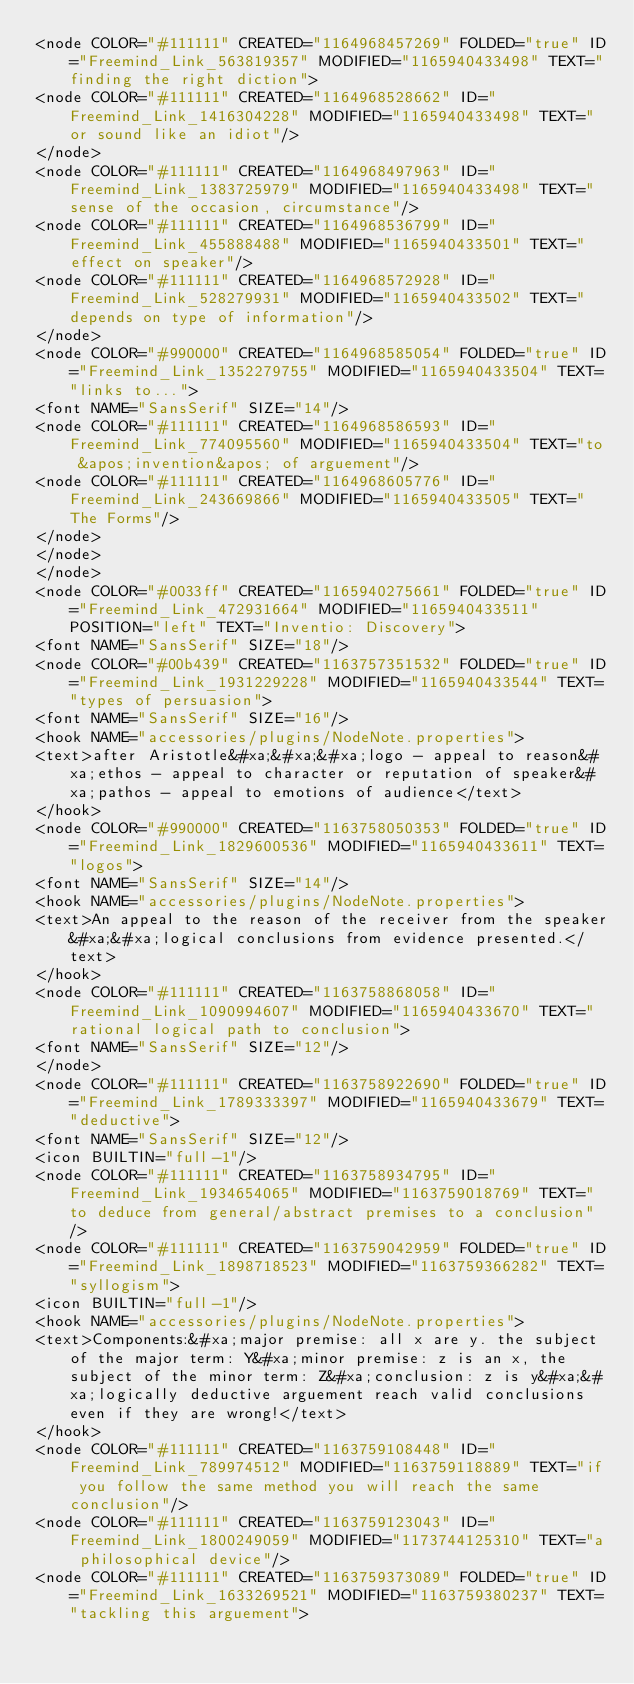Convert code to text. <code><loc_0><loc_0><loc_500><loc_500><_ObjectiveC_><node COLOR="#111111" CREATED="1164968457269" FOLDED="true" ID="Freemind_Link_563819357" MODIFIED="1165940433498" TEXT="finding the right diction">
<node COLOR="#111111" CREATED="1164968528662" ID="Freemind_Link_1416304228" MODIFIED="1165940433498" TEXT="or sound like an idiot"/>
</node>
<node COLOR="#111111" CREATED="1164968497963" ID="Freemind_Link_1383725979" MODIFIED="1165940433498" TEXT="sense of the occasion, circumstance"/>
<node COLOR="#111111" CREATED="1164968536799" ID="Freemind_Link_455888488" MODIFIED="1165940433501" TEXT="effect on speaker"/>
<node COLOR="#111111" CREATED="1164968572928" ID="Freemind_Link_528279931" MODIFIED="1165940433502" TEXT="depends on type of information"/>
</node>
<node COLOR="#990000" CREATED="1164968585054" FOLDED="true" ID="Freemind_Link_1352279755" MODIFIED="1165940433504" TEXT="links to...">
<font NAME="SansSerif" SIZE="14"/>
<node COLOR="#111111" CREATED="1164968586593" ID="Freemind_Link_774095560" MODIFIED="1165940433504" TEXT="to &apos;invention&apos; of arguement"/>
<node COLOR="#111111" CREATED="1164968605776" ID="Freemind_Link_243669866" MODIFIED="1165940433505" TEXT="The Forms"/>
</node>
</node>
</node>
<node COLOR="#0033ff" CREATED="1165940275661" FOLDED="true" ID="Freemind_Link_472931664" MODIFIED="1165940433511" POSITION="left" TEXT="Inventio: Discovery">
<font NAME="SansSerif" SIZE="18"/>
<node COLOR="#00b439" CREATED="1163757351532" FOLDED="true" ID="Freemind_Link_1931229228" MODIFIED="1165940433544" TEXT="types of persuasion">
<font NAME="SansSerif" SIZE="16"/>
<hook NAME="accessories/plugins/NodeNote.properties">
<text>after Aristotle&#xa;&#xa;&#xa;logo - appeal to reason&#xa;ethos - appeal to character or reputation of speaker&#xa;pathos - appeal to emotions of audience</text>
</hook>
<node COLOR="#990000" CREATED="1163758050353" FOLDED="true" ID="Freemind_Link_1829600536" MODIFIED="1165940433611" TEXT="logos">
<font NAME="SansSerif" SIZE="14"/>
<hook NAME="accessories/plugins/NodeNote.properties">
<text>An appeal to the reason of the receiver from the speaker&#xa;&#xa;logical conclusions from evidence presented.</text>
</hook>
<node COLOR="#111111" CREATED="1163758868058" ID="Freemind_Link_1090994607" MODIFIED="1165940433670" TEXT="rational logical path to conclusion">
<font NAME="SansSerif" SIZE="12"/>
</node>
<node COLOR="#111111" CREATED="1163758922690" FOLDED="true" ID="Freemind_Link_1789333397" MODIFIED="1165940433679" TEXT="deductive">
<font NAME="SansSerif" SIZE="12"/>
<icon BUILTIN="full-1"/>
<node COLOR="#111111" CREATED="1163758934795" ID="Freemind_Link_1934654065" MODIFIED="1163759018769" TEXT="to deduce from general/abstract premises to a conclusion"/>
<node COLOR="#111111" CREATED="1163759042959" FOLDED="true" ID="Freemind_Link_1898718523" MODIFIED="1163759366282" TEXT="syllogism">
<icon BUILTIN="full-1"/>
<hook NAME="accessories/plugins/NodeNote.properties">
<text>Components:&#xa;major premise: all x are y. the subject of the major term: Y&#xa;minor premise: z is an x, the subject of the minor term: Z&#xa;conclusion: z is y&#xa;&#xa;logically deductive arguement reach valid conclusions even if they are wrong!</text>
</hook>
<node COLOR="#111111" CREATED="1163759108448" ID="Freemind_Link_789974512" MODIFIED="1163759118889" TEXT="if you follow the same method you will reach the same conclusion"/>
<node COLOR="#111111" CREATED="1163759123043" ID="Freemind_Link_1800249059" MODIFIED="1173744125310" TEXT="a philosophical device"/>
<node COLOR="#111111" CREATED="1163759373089" FOLDED="true" ID="Freemind_Link_1633269521" MODIFIED="1163759380237" TEXT="tackling this arguement"></code> 